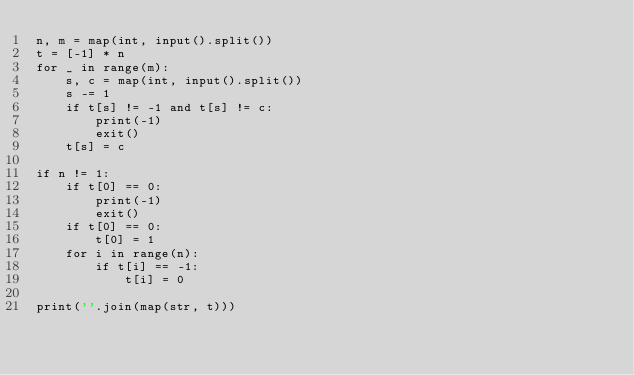<code> <loc_0><loc_0><loc_500><loc_500><_Python_>n, m = map(int, input().split())
t = [-1] * n
for _ in range(m):
    s, c = map(int, input().split())
    s -= 1
    if t[s] != -1 and t[s] != c:
        print(-1)
        exit()
    t[s] = c

if n != 1:
    if t[0] == 0:
        print(-1)
        exit()
    if t[0] == 0:
        t[0] = 1
    for i in range(n):
        if t[i] == -1:
            t[i] = 0
    
print(''.join(map(str, t)))</code> 